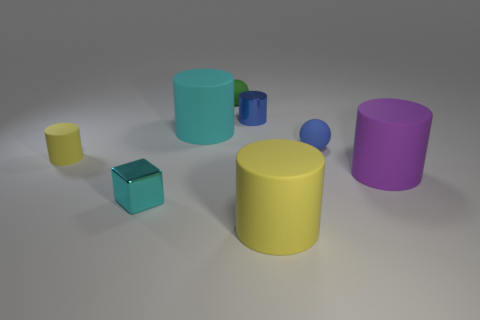There is a small cylinder that is made of the same material as the big purple cylinder; what is its color?
Keep it short and to the point. Yellow. Do the cube and the cyan rubber thing have the same size?
Keep it short and to the point. No. What material is the tiny cube?
Give a very brief answer. Metal. What material is the yellow cylinder that is the same size as the purple matte object?
Give a very brief answer. Rubber. Is there a blue cylinder of the same size as the green sphere?
Provide a short and direct response. Yes. Are there an equal number of green rubber balls behind the metal cylinder and tiny yellow objects behind the blue sphere?
Provide a succinct answer. No. Is the number of small yellow cylinders greater than the number of brown cylinders?
Give a very brief answer. Yes. How many matte things are balls or cyan objects?
Provide a short and direct response. 3. What number of tiny matte things have the same color as the tiny metallic cylinder?
Ensure brevity in your answer.  1. What is the material of the yellow cylinder that is to the left of the yellow object in front of the big thing right of the blue matte ball?
Offer a very short reply. Rubber. 